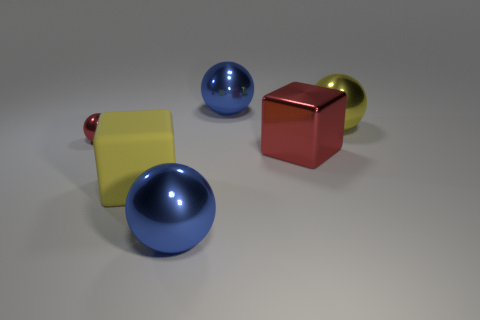Is there anything else that has the same material as the big yellow block?
Provide a succinct answer. No. Are there the same number of blue objects on the right side of the yellow shiny thing and small red objects that are to the right of the small red ball?
Ensure brevity in your answer.  Yes. Does the yellow object that is behind the large matte cube have the same shape as the tiny red object?
Your answer should be compact. Yes. Is the shape of the large yellow matte thing the same as the yellow metallic object?
Provide a short and direct response. No. How many metal objects are either blue objects or big balls?
Offer a very short reply. 3. There is another thing that is the same color as the tiny metal object; what material is it?
Your answer should be compact. Metal. Does the red metal ball have the same size as the rubber block?
Provide a short and direct response. No. What number of objects are either blue objects or metal things that are in front of the yellow ball?
Offer a terse response. 4. What is the material of the red block that is the same size as the yellow sphere?
Offer a very short reply. Metal. There is a large object that is in front of the small metallic sphere and behind the large yellow rubber thing; what material is it made of?
Ensure brevity in your answer.  Metal. 